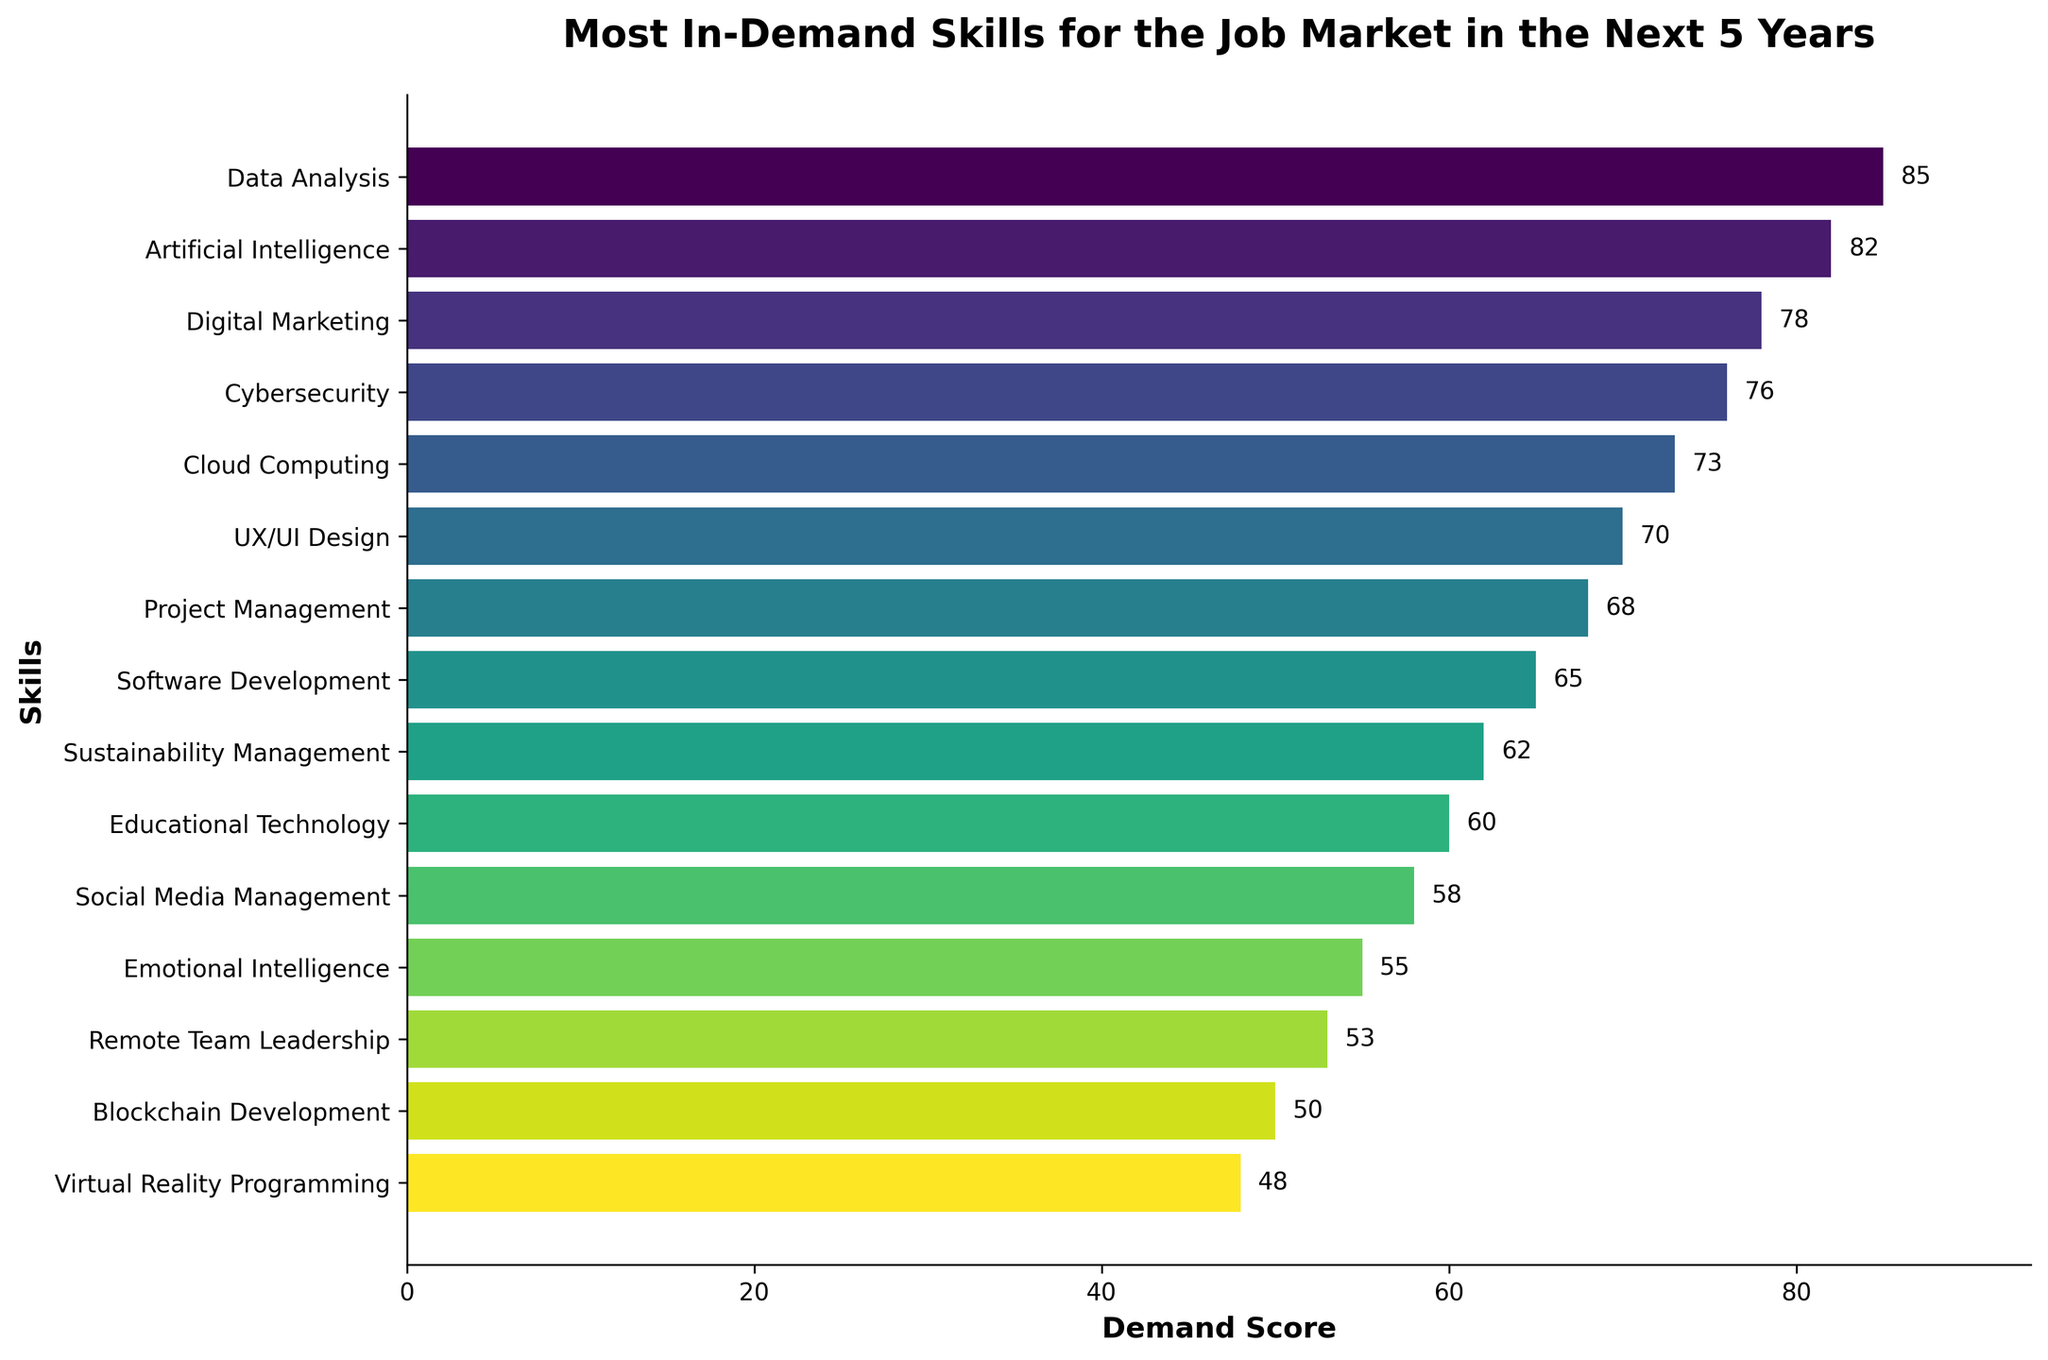What skill has the highest demand score? By interpreting the data, we see that the longest bar represents the highest demand score, which corresponds to Data Analysis with a demand score of 85.
Answer: Data Analysis Which skill has a lower demand score, Cybersecurity or Cloud Computing? Looking at the bars representing Cybersecurity and Cloud Computing, Cybersecurity's bar is slightly longer, indicating a demand score of 76, whereas Cloud Computing has a score of 73.
Answer: Cloud Computing What is the difference in demand score between Artificial Intelligence and Emotional Intelligence? The demand score for Artificial Intelligence is 82 and for Emotional Intelligence is 55. Subtract 55 from 82 to get the difference, which is 27.
Answer: 27 What are the skills with demand scores higher than 75? Scanning the bars, we see that the skills with demand scores higher than 75 are Data Analysis (85), Artificial Intelligence (82), Digital Marketing (78), and Cybersecurity (76).
Answer: Data Analysis, Artificial Intelligence, Digital Marketing, Cybersecurity How much higher is the demand score for UX/UI Design compared to Blockchain Development? The demand score for UX/UI Design is 70 and for Blockchain Development is 50. Subtract 50 from 70 to get 20.
Answer: 20 Which two skills have the closest demand scores, and what are their values? By comparing the lengths of the bars, Remote Team Leadership (53) and Blockchain Development (50) have the closest scores, with a difference of just 3 points.
Answer: Remote Team Leadership and Blockchain Development; 53 and 50 What is the average demand score for the top 5 in-demand skills? The top 5 demand scores are Data Analysis (85), Artificial Intelligence (82), Digital Marketing (78), Cybersecurity (76), and Cloud Computing (73). The average is calculated as (85 + 82 + 78 + 76 + 73) / 5 = 78.8.
Answer: 78.8 Which skill is indicated by the shortest bar in the chart? The shortest bar in the chart corresponds to Virtual Reality Programming, which has the lowest demand score of 48.
Answer: Virtual Reality Programming 